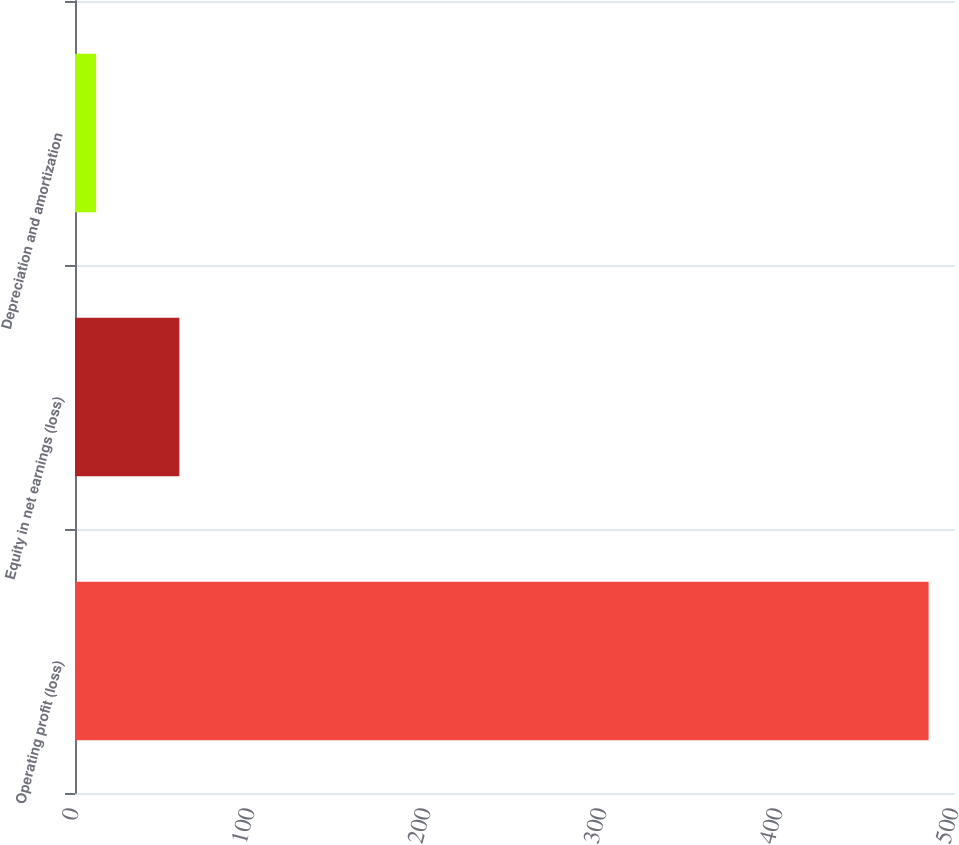Convert chart to OTSL. <chart><loc_0><loc_0><loc_500><loc_500><bar_chart><fcel>Operating profit (loss)<fcel>Equity in net earnings (loss)<fcel>Depreciation and amortization<nl><fcel>485<fcel>59.3<fcel>12<nl></chart> 